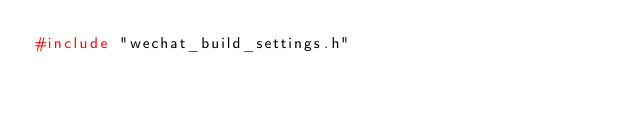Convert code to text. <code><loc_0><loc_0><loc_500><loc_500><_C++_>#include "wechat_build_settings.h"</code> 